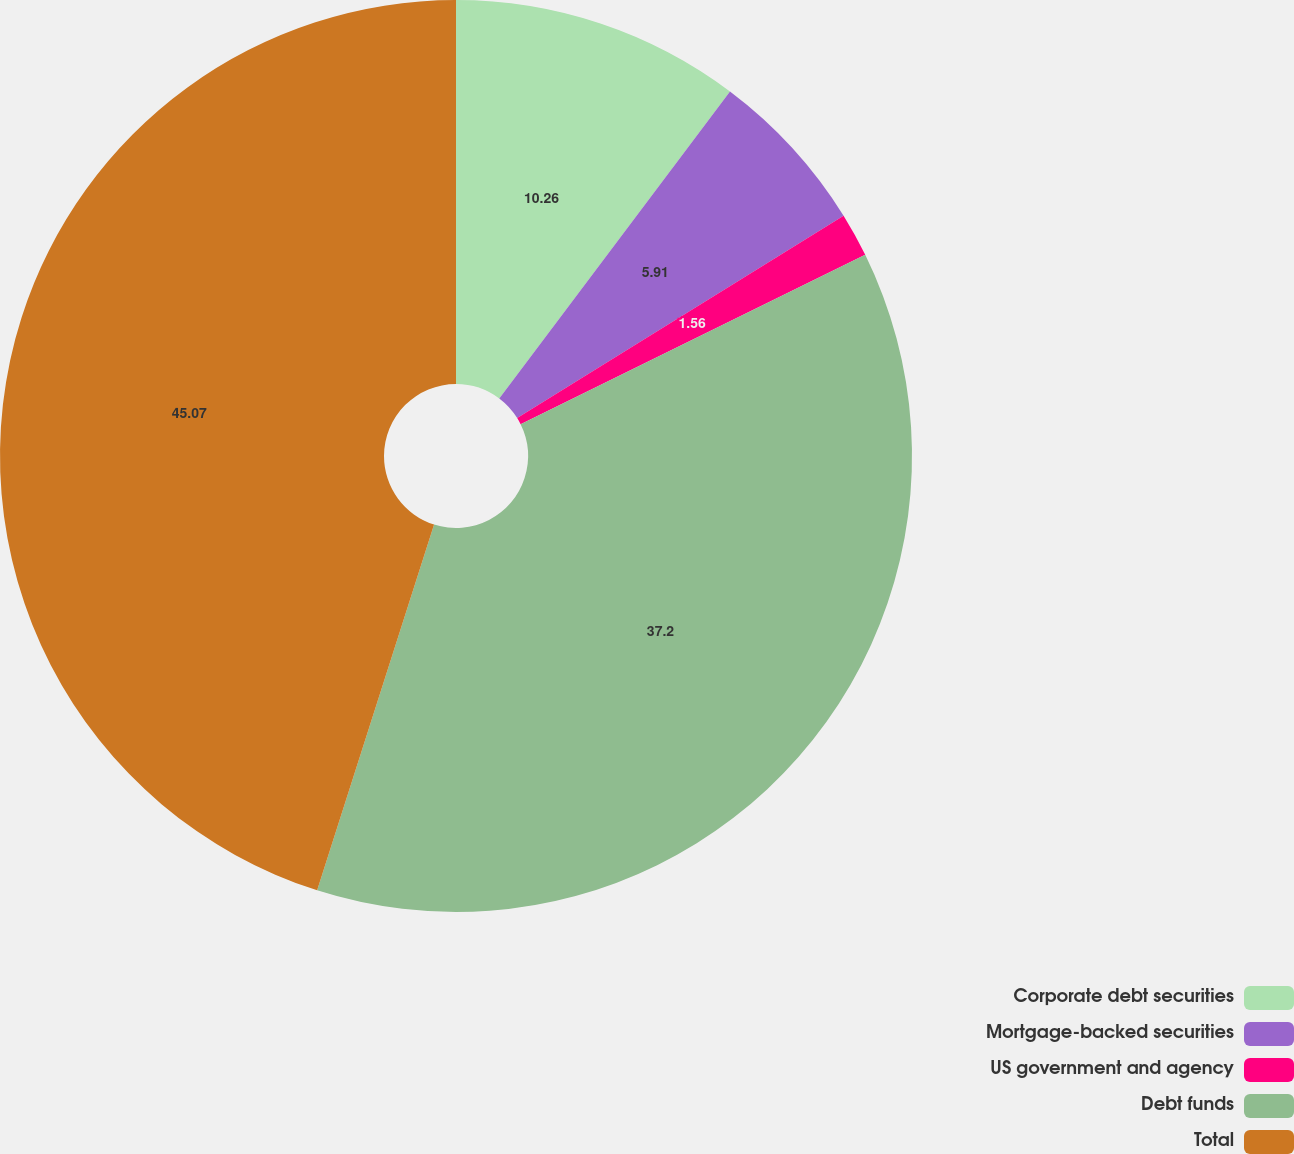Convert chart to OTSL. <chart><loc_0><loc_0><loc_500><loc_500><pie_chart><fcel>Corporate debt securities<fcel>Mortgage-backed securities<fcel>US government and agency<fcel>Debt funds<fcel>Total<nl><fcel>10.26%<fcel>5.91%<fcel>1.56%<fcel>37.2%<fcel>45.08%<nl></chart> 